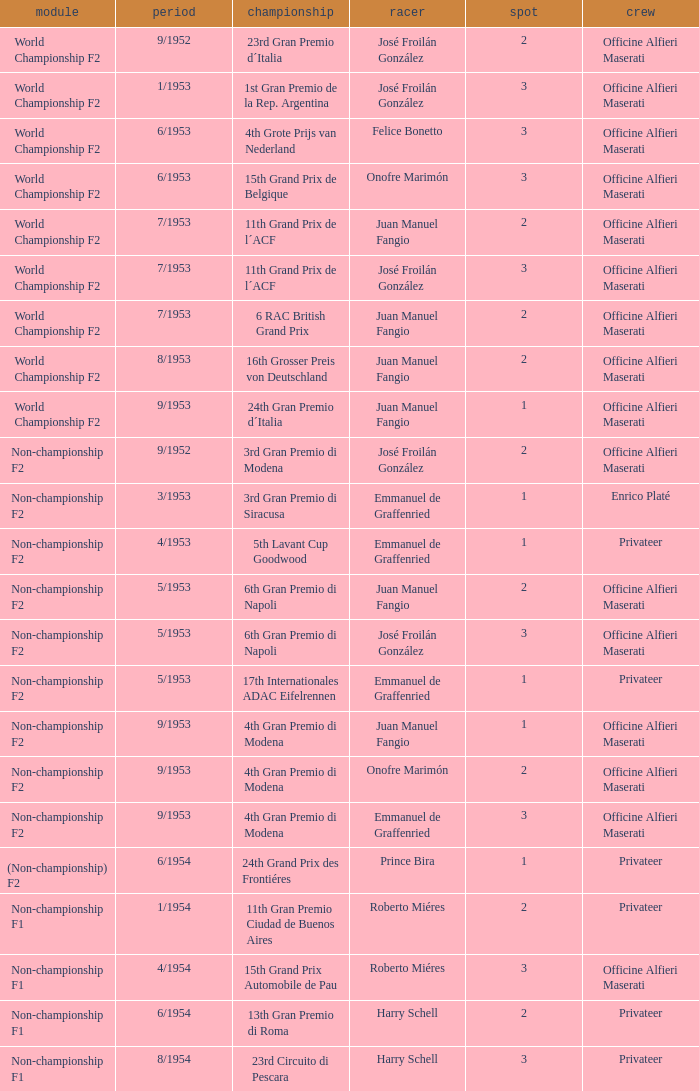What class has the date of 8/1954? Non-championship F1. 